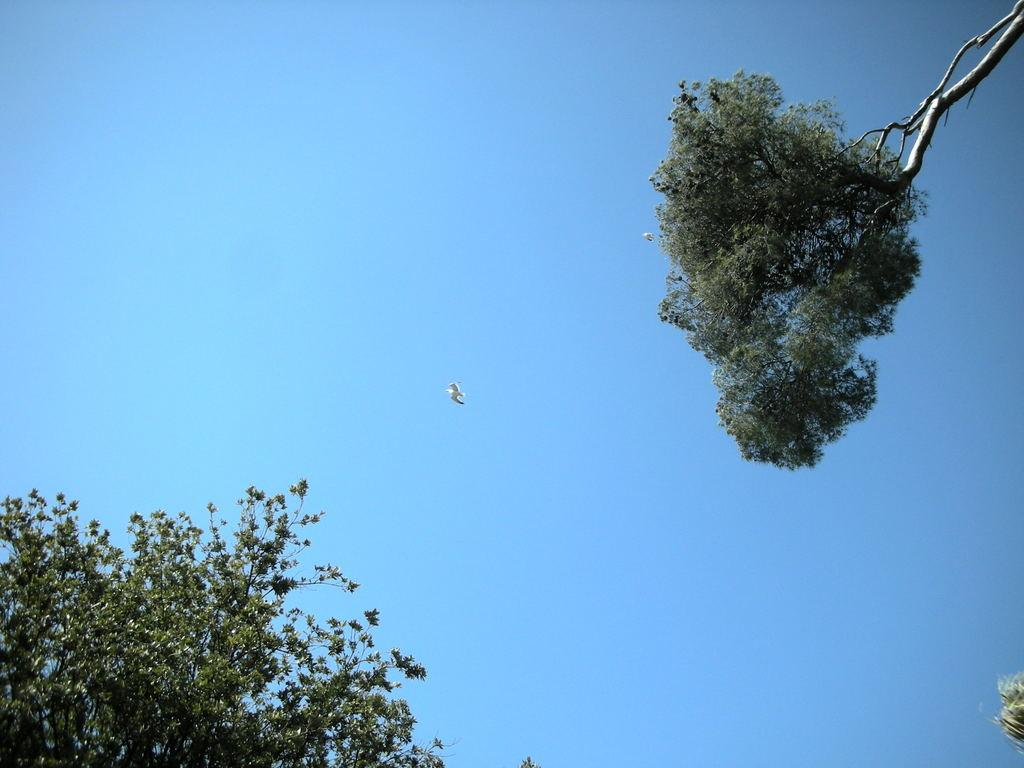What is the main subject of the image? There is a bird in the sky in the center of the image. What can be seen in the top right corner of the image? There are trees visible in the top right corner of the image. What can be seen in the bottom left corner of the image? There are trees visible in the bottom left corner of the image. What type of songs is the servant singing in the image? There is no servant or songs present in the image; it features a bird in the sky and trees in the corners. 